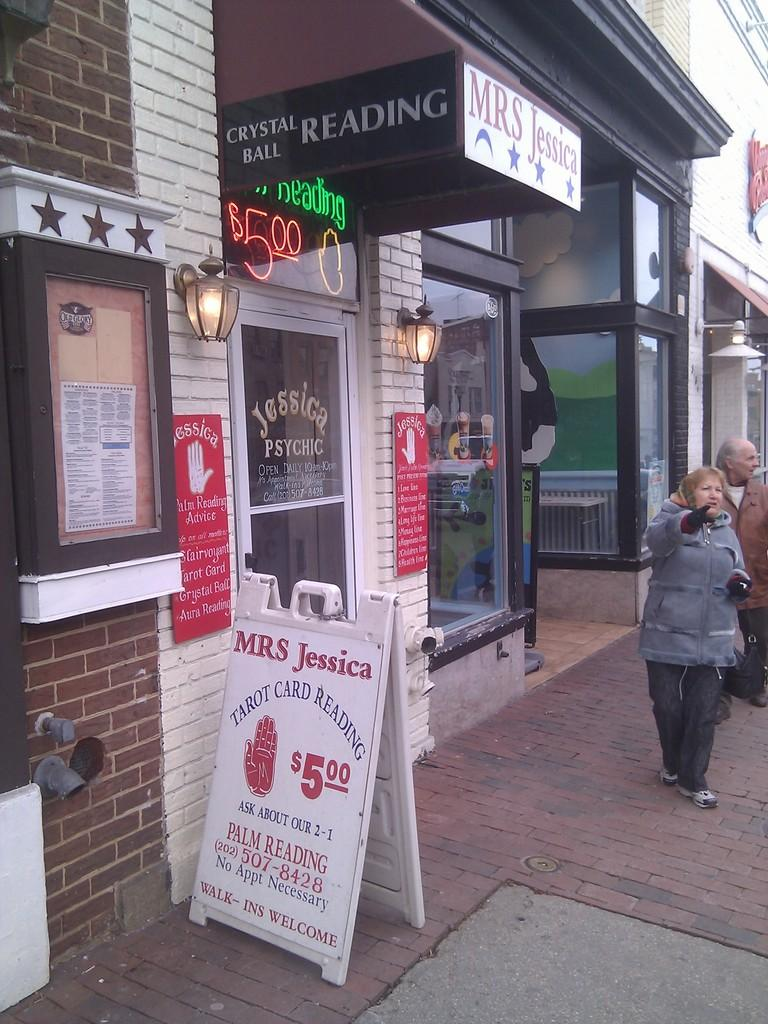What type of structures can be seen in the image? There are buildings in the image. What are the boards used for in the image? The boards are not explicitly described in the facts, so we cannot determine their purpose. Who or what is present in the image? There are people in the image. What type of signage is visible in the image? There are posters in the image. Can you read any text in the image? Yes, there is text visible in the image. What else can be seen in the image besides the mentioned elements? There are objects in the image. What is the ground surface like in the image? There is a walkway at the bottom of the image. Can you tell me where the nearest hospital is in the image? There is no information about a hospital in the image or the provided facts. How does the walkway shake in the image? The walkway does not shake in the image; it is a stationary surface. 